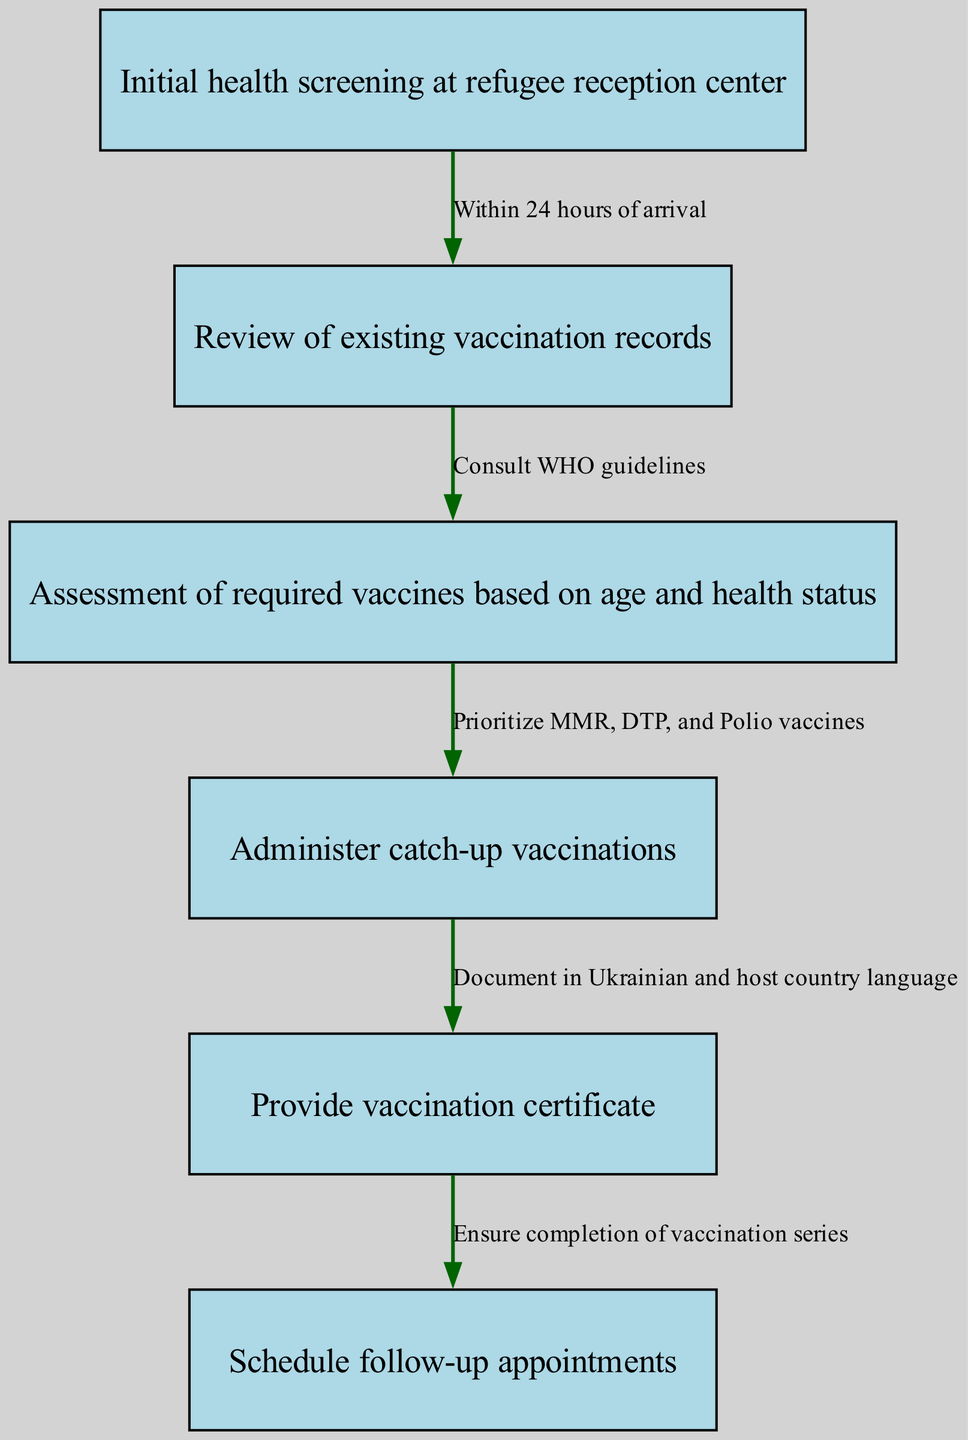What is the first step in the vaccination pathway? The first node in the diagram describes the initial action to be taken, which is the "Initial health screening at refugee reception center."
Answer: Initial health screening at refugee reception center How many nodes are present in the diagram? The diagram lists a total of six distinct nodes representing different steps in the vaccination process.
Answer: 6 What is the relationship between the "Initial health screening at refugee reception center" and "Review of existing vaccination records"? The edge between these two nodes indicates that the review of vaccination records takes place "Within 24 hours of arrival" after the initial health screening.
Answer: Within 24 hours of arrival Which vaccines should be prioritized according to the diagram? According to the path, the prioritization of vaccines includes MMR, DTP, and Polio, as specified in the node connected to the assessment of vaccines.
Answer: MMR, DTP, and Polio What must be documented when administering catch-up vaccinations? The diagram clearly states that the vaccination certificate must be documented in both Ukrainian and the host country language after the catch-up vaccinations are administered.
Answer: In Ukrainian and host country language How does the process ensure completion of the vaccination series? The final node emphasizes the scheduling of follow-up appointments to ensure that individuals complete their vaccination series, thus indicating a clear link to maintaining vaccination continuity.
Answer: Schedule follow-up appointments 